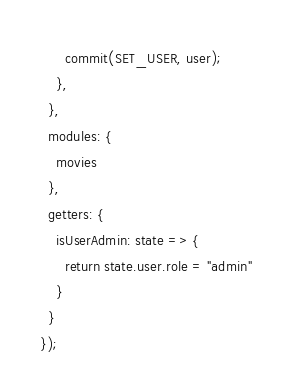Convert code to text. <code><loc_0><loc_0><loc_500><loc_500><_JavaScript_>      commit(SET_USER, user);
    },
  },
  modules: {
    movies
  },
  getters: {
    isUserAdmin: state => {
      return state.user.role = "admin"
    }
  }
});
</code> 